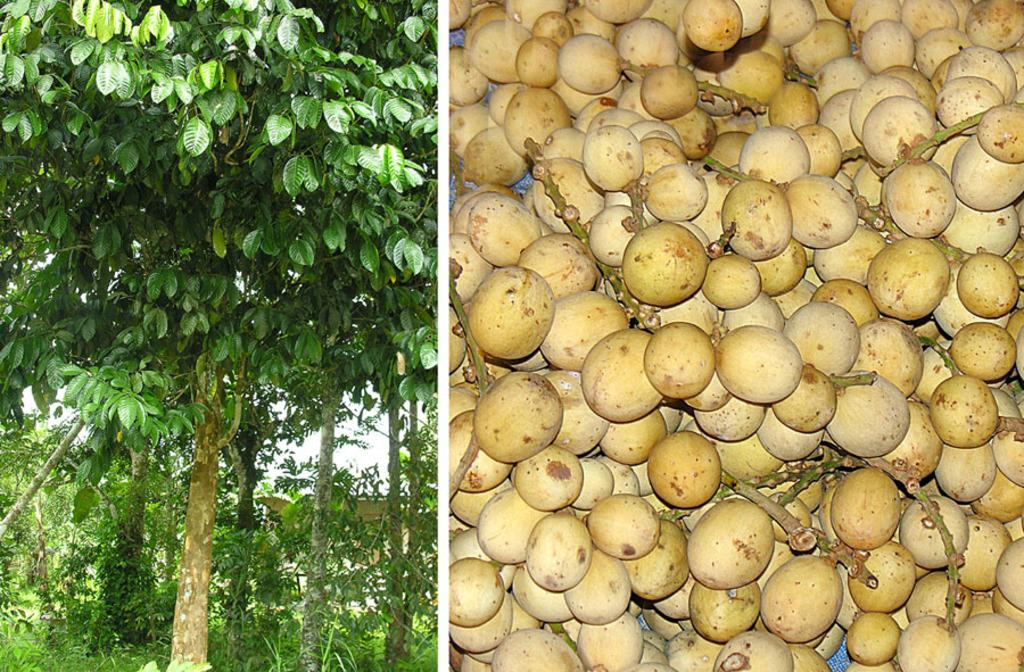What types of natural elements are present in the collage? The collage contains trees and plants. What part of the natural environment is visible in the collage? The sky is visible in the collage. What type of food items can be seen in the collage? The collage contains fruits on a surface. What is the purpose of the doll in the collage? There is no doll present in the collage. What can be observed about the fruits in the collage? The fruits are visible on a surface in the collage. 